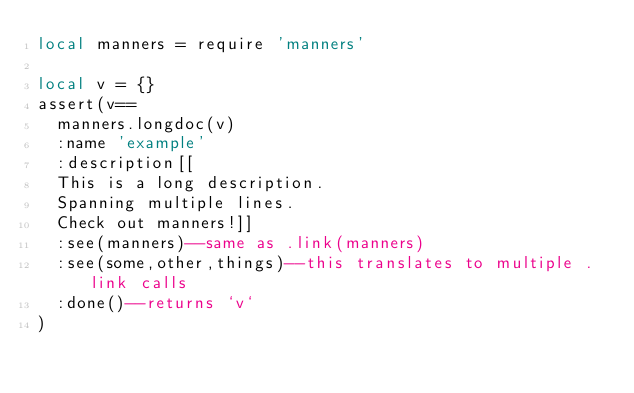<code> <loc_0><loc_0><loc_500><loc_500><_Lua_>local manners = require 'manners'

local v = {}
assert(v==
	manners.longdoc(v)
	:name 'example'
	:description[[
	This is a long description.
	Spanning multiple lines.
	Check out manners!]]
	:see(manners)--same as .link(manners)
	:see(some,other,things)--this translates to multiple .link calls
	:done()--returns `v`
)
</code> 